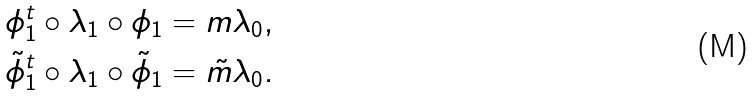Convert formula to latex. <formula><loc_0><loc_0><loc_500><loc_500>\phi _ { 1 } ^ { t } \circ \lambda _ { 1 } \circ \phi _ { 1 } = m \lambda _ { 0 } , \\ \tilde { \phi } _ { 1 } ^ { t } \circ \lambda _ { 1 } \circ \tilde { \phi } _ { 1 } = \tilde { m } \lambda _ { 0 } .</formula> 